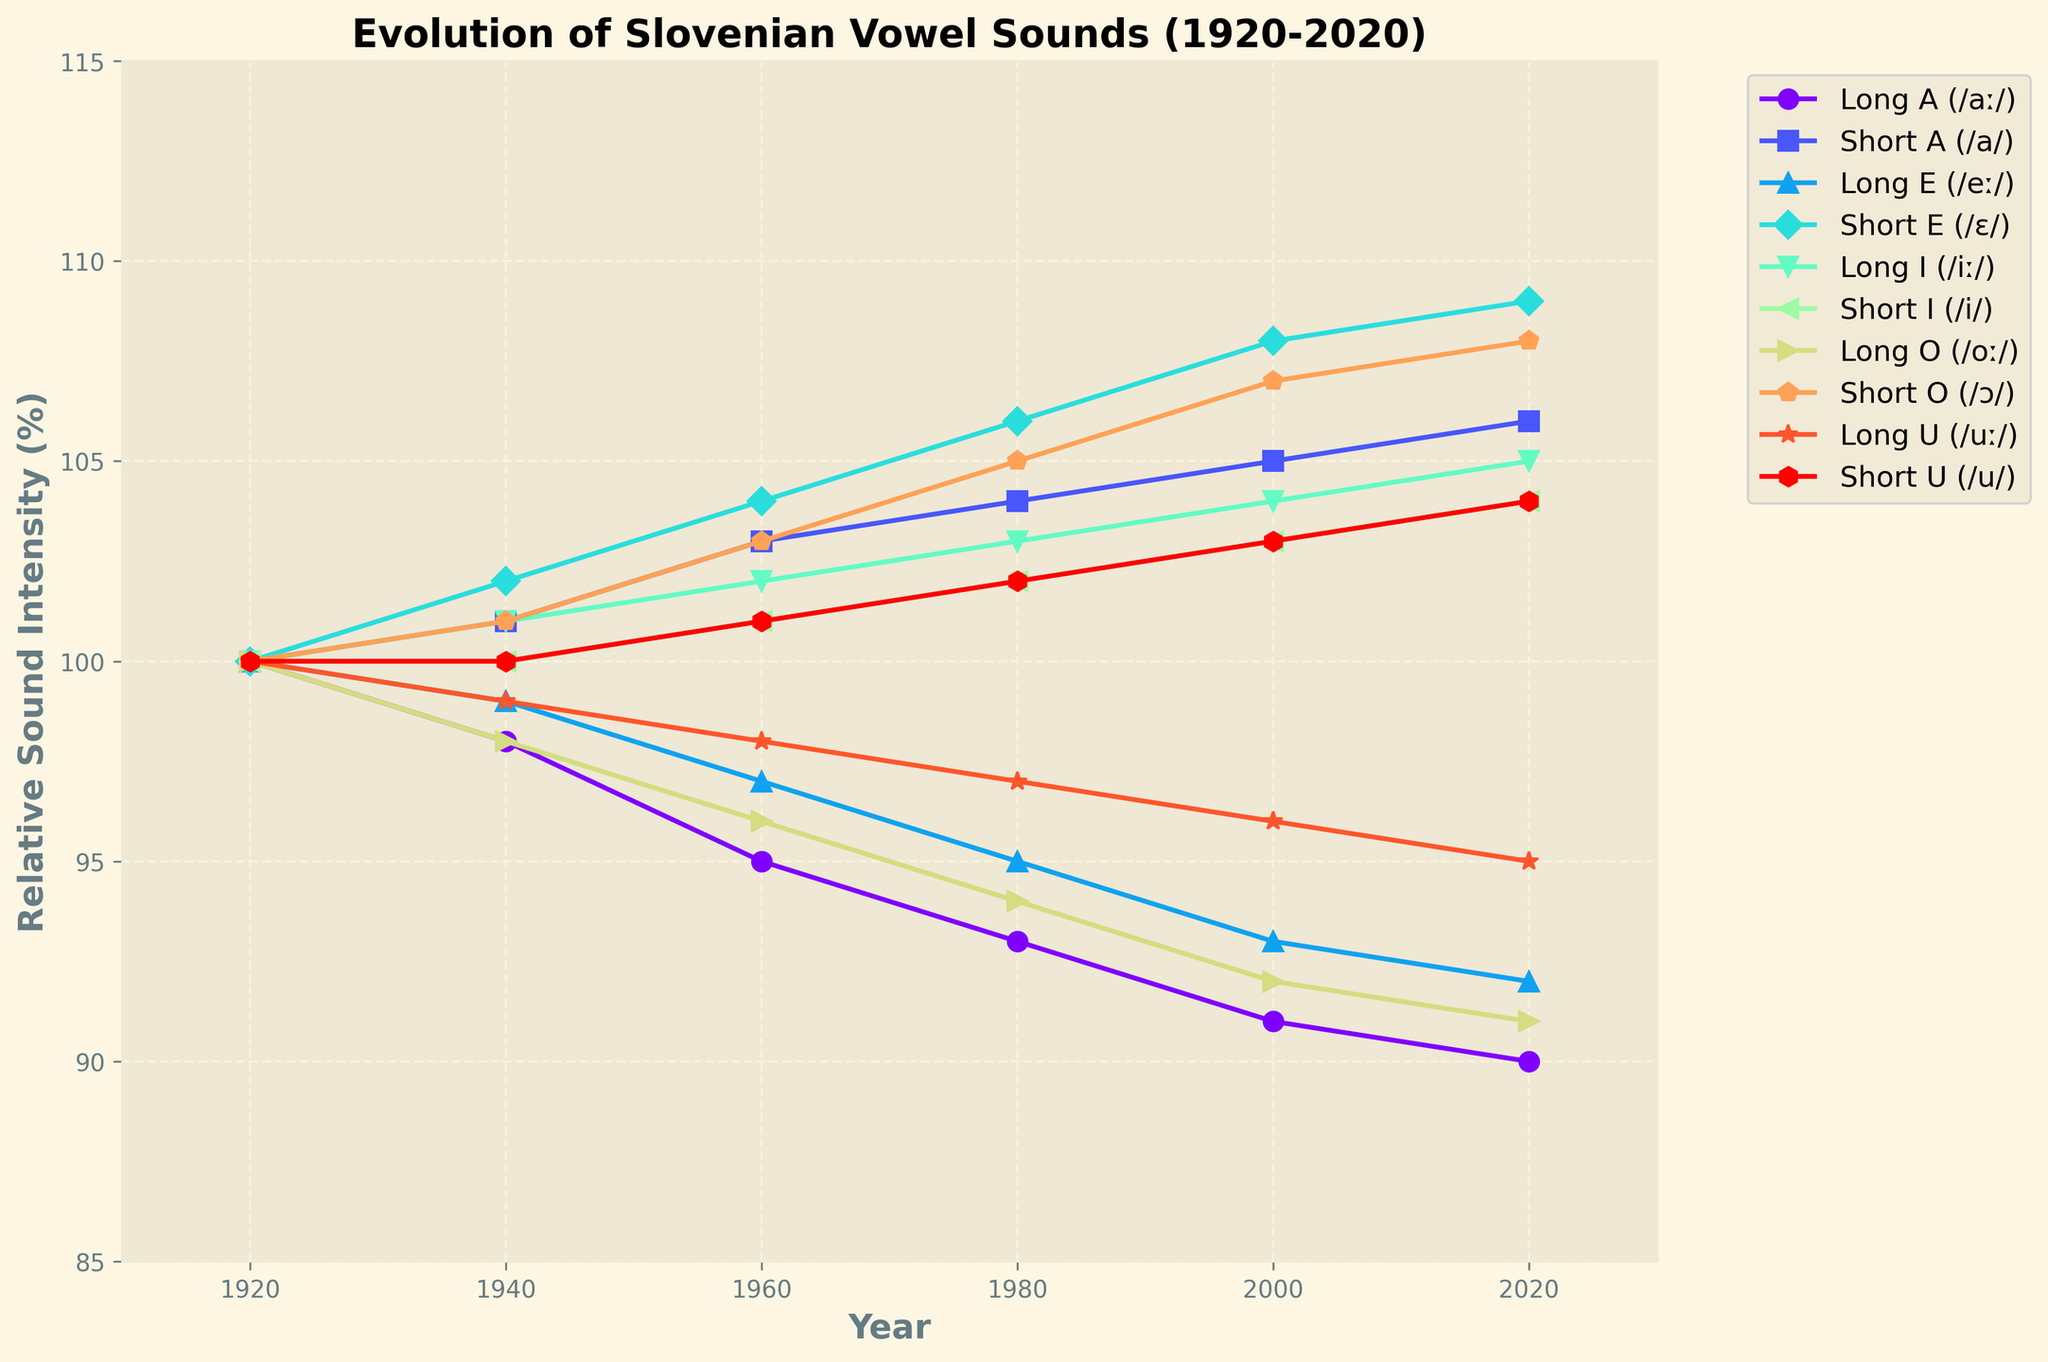Which vowel sound maintained the most consistent relative sound intensity from 1920 to 2020? Upon observing the trend lines, the Short I (/i/) appears to have the smallest variation in relative sound intensity, hovering closely around the 100% mark, indicating the most consistency over the century.
Answer: Short I (/i/) Which vowel sound shows the greatest decline in relative sound intensity from 1920 to 2020? From the figure, the Long A (/aː/) steadily decreases from 100% in 1920 to 90% in 2020, indicating the greatest decline among all the vowel sounds plotted.
Answer: Long A (/aː/) How does the relative sound intensity of Long E (/eː/) in 1980 compare with that of Short E (/ɛ/) in the same year? According to the graph, the relative sound intensity of Long E (/eː/) in 1980 is roughly 95%, while Short E (/ɛ/) is around 106%, showing that Short E (/ɛ/) is higher.
Answer: Short E (/ɛ/) is higher Which vowel sound had the highest relative sound intensity in 2020? Looking at the endpoint for each vowel sound's trend line in 2020, Short E (/ɛ/) reaches approximately 109%, making it the highest relative sound intensity among all the vowel sounds in 2020.
Answer: Short E (/ɛ/) What is the combined relative sound intensity of Short O (/ɔ/) and Short U (/u/) in the year 2000? Referring to the values in the figure, Short O (/ɔ/) has a relative sound intensity of 107% and Short U (/u/) has 103% in 2000. Adding these together gives the combined intensity of 107 + 103 = 210%.
Answer: 210% Which vowel sounds have diverging trends, and what are their relative directions from 1920 to 2020? Analyzing the overall trends, Long A (/aː/) shows a downward trend, while Short A (/a/) exhibits an upward trend. Similarly, Long E (/eː/) declines, whereas Short E (/ɛ/) increases. These sound pairs have diverging trends in relative directions.
Answer: Long A (/aː/) down, Short A (/a/) up; Long E (/eː/) down, Short E (/ɛ/) up What is the average relative sound intensity of the Long and Short O (/oː/ and /ɔ/) in 1940? For 1940, the relative sound intensities are 98% for Long O (/oː/) and 101% for Short O (/ɔ/). The average is: (98 + 101) / 2 = 99.5%.
Answer: 99.5% Is there any vowel sound whose relative intensity steadily increased over each time period from 1920 to 2020? By inspecting the graph, Short E (/ɛ/) increases consistently from 100% in 1920 to 109% in 2020, showing a steady rise across all the periods.
Answer: Short E (/ɛ/) How does the variation in relative sound intensity of Long I (/iː/) compare from 1920 to 2020? The graph shows Long I (/iː/) rising from 100% in 1920 to 105% in 2020, a total increase of 5%, indicating a moderate upward trend.
Answer: Moderately upward, total increase of 5% 